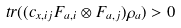Convert formula to latex. <formula><loc_0><loc_0><loc_500><loc_500>\ t r ( ( c _ { x , i j } F _ { a , i } \otimes F _ { a , j } ) \rho _ { a } ) > 0</formula> 